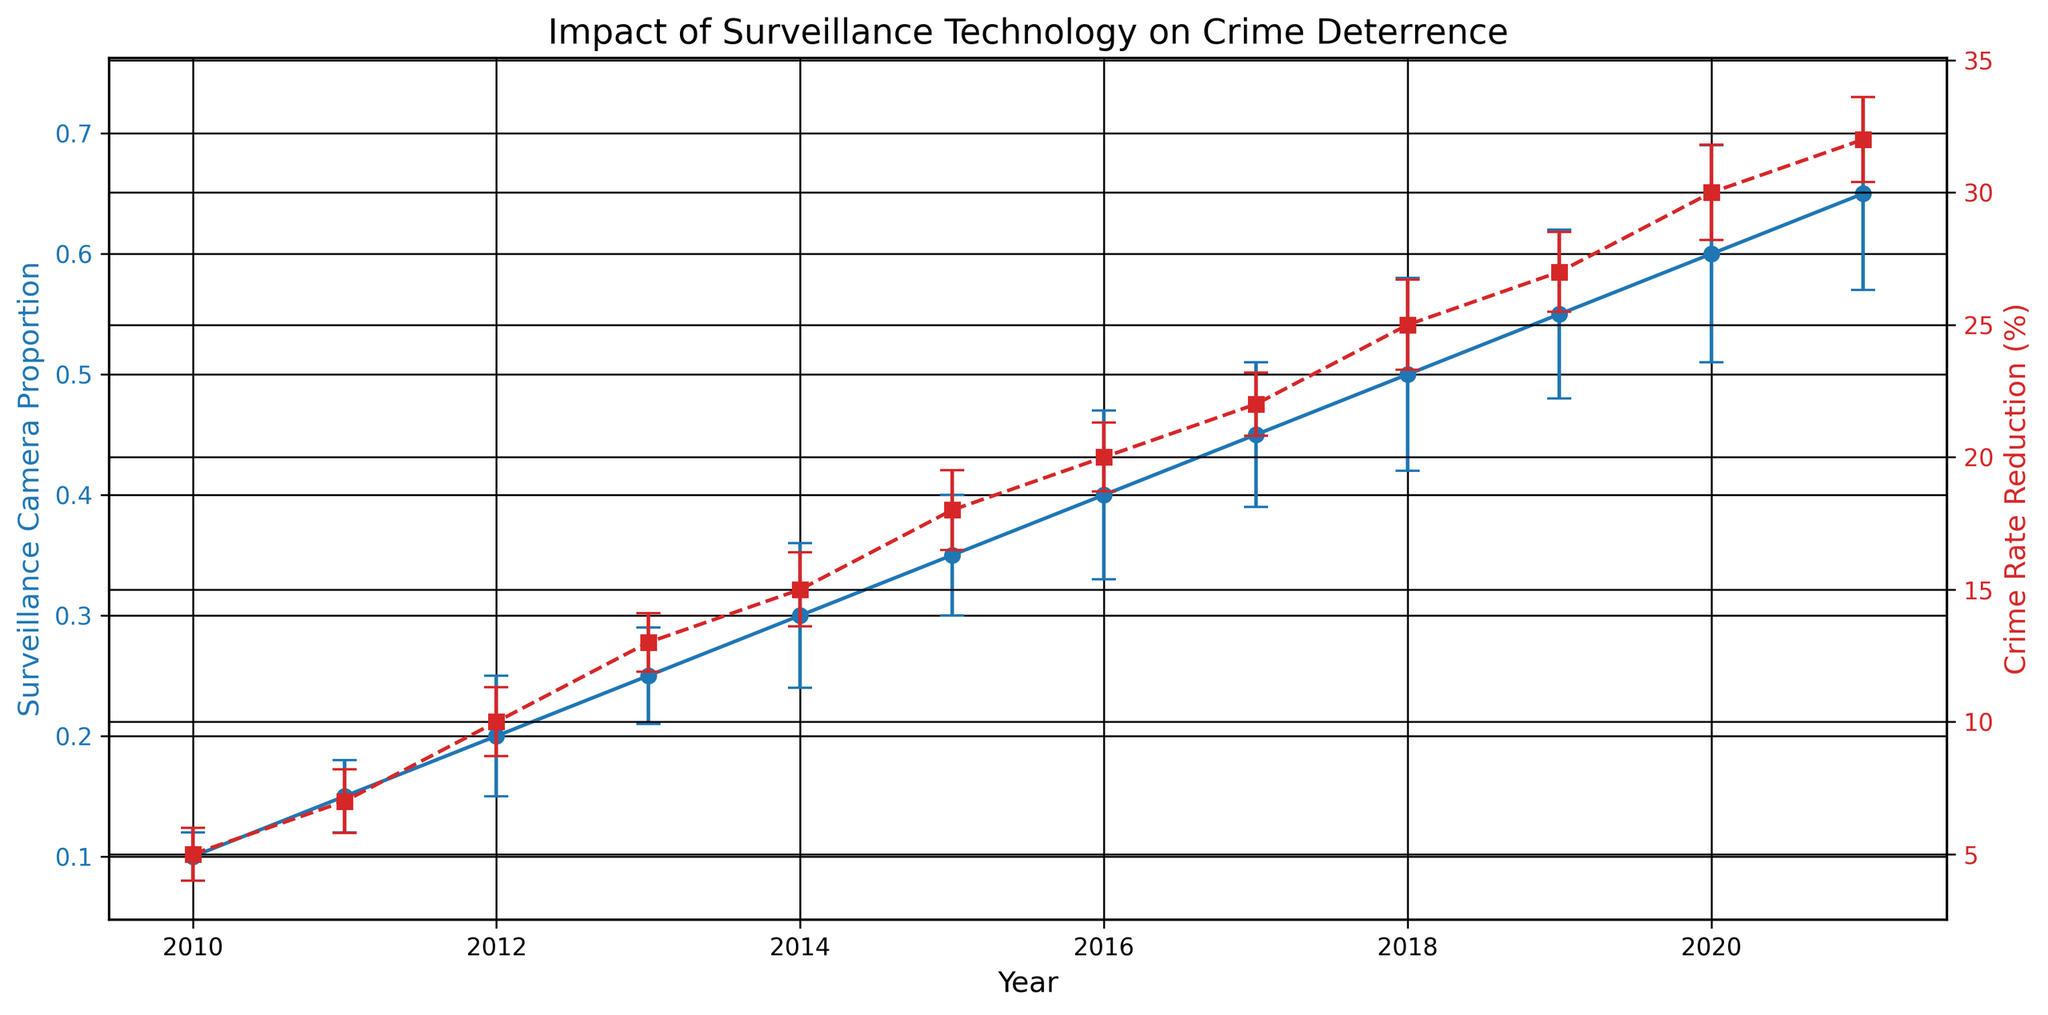What is the general trend in the Surveillance Camera Proportion over the years? From 2010 to 2021, the Surveillance Camera Proportion consistently increases each year, as shown by a series of upward-pointing blue markers connected by a line trending upwards.
Answer: Increasing How does the Crime Rate Reduction compare between 2010 and 2021? In 2010, the Crime Rate Reduction is at 5%, denoted by a red square marker, whereas in 2021, it is at 32%, indicated by another red square marker. Comparing these, there's a significant increase from 5% to 32%.
Answer: Crime Rate Reduction increased Which year shows the highest Crime Rate Reduction and what is its value? The year 2021 shows the highest Crime Rate Reduction value at 32%, indicated by the highest red square marker on the plot.
Answer: 2021, 32% What is the difference in Surveillance Camera Proportion and Crime Rate Reduction between 2015 and 2017? In 2015, the Surveillance Camera Proportion is 0.35 and Crime Rate Reduction is 18%, whereas in 2017, the Surveillance Camera Proportion is 0.45 and Crime Rate Reduction is 22%. The differences are 0.45 - 0.35 = 0.1 and 22 - 18 = 4, respectively.
Answer: Surveillance: 0.1, Crime Rate: 4% What is the average Surveillance Camera Proportion from 2010 to 2021? The Surveillance Camera Proportions for each year are: 0.10, 0.15, 0.20, 0.25, 0.30, 0.35, 0.40, 0.45, 0.50, 0.55, 0.60, and 0.65. Adding these and dividing by the number of years (12) gives the average: (0.1+0.15+0.2+0.25+0.3+0.35+0.4+0.45+0.5+0.55+0.6+0.65) / 12 = 4.5 / 12 = 0.375.
Answer: 0.375 Compare the Error of Surveillance Camera Proportion in 2012 and 2018. Which year had a higher error? In 2012, the error for Surveillance Camera Proportion is 0.05, and in 2018 it is 0.08 as indicated by the error bars extending vertically. Thus, the year 2018 had a higher error.
Answer: 2018 What is the relationship between Surveillance Camera Proportion and Crime Rate Reduction? As the Surveillance Camera Proportion increases from 0.10 to 0.65 from 2010 to 2021, the Crime Rate Reduction also increases from 5% to 32%. This consistent upward trend in both metrics suggests a positive correlation between Surveillance Camera Proportion and Crime Rate Reduction.
Answer: Positive correlation How much did the Crime Rate Reduction increase on average each year? From 2010 to 2021, the Crime Rate Reduction increased from 5% to 32%. The total increase is 32 - 5 = 27%. Over 11 years, the average annual increase is 27% / 11 = 2.45%.
Answer: 2.45% In which year did the Surveillance Camera Proportion first reach 0.50 or more, and what was the corresponding Crime Rate Reduction? The year 2018 first shows a Surveillance Camera Proportion of 0.50 (blue marker), with the corresponding Crime Rate Reduction being 25% (red square marker).
Answer: 2018, 25% Which year's Crime Rate Reduction has the highest error value, and what is it? The highest error value for Crime Rate Reduction is 1.8% in 2020, indicated by the longest error bar extending horizontally for the red square marker representing post-2020.
Answer: 2020, 1.8% 